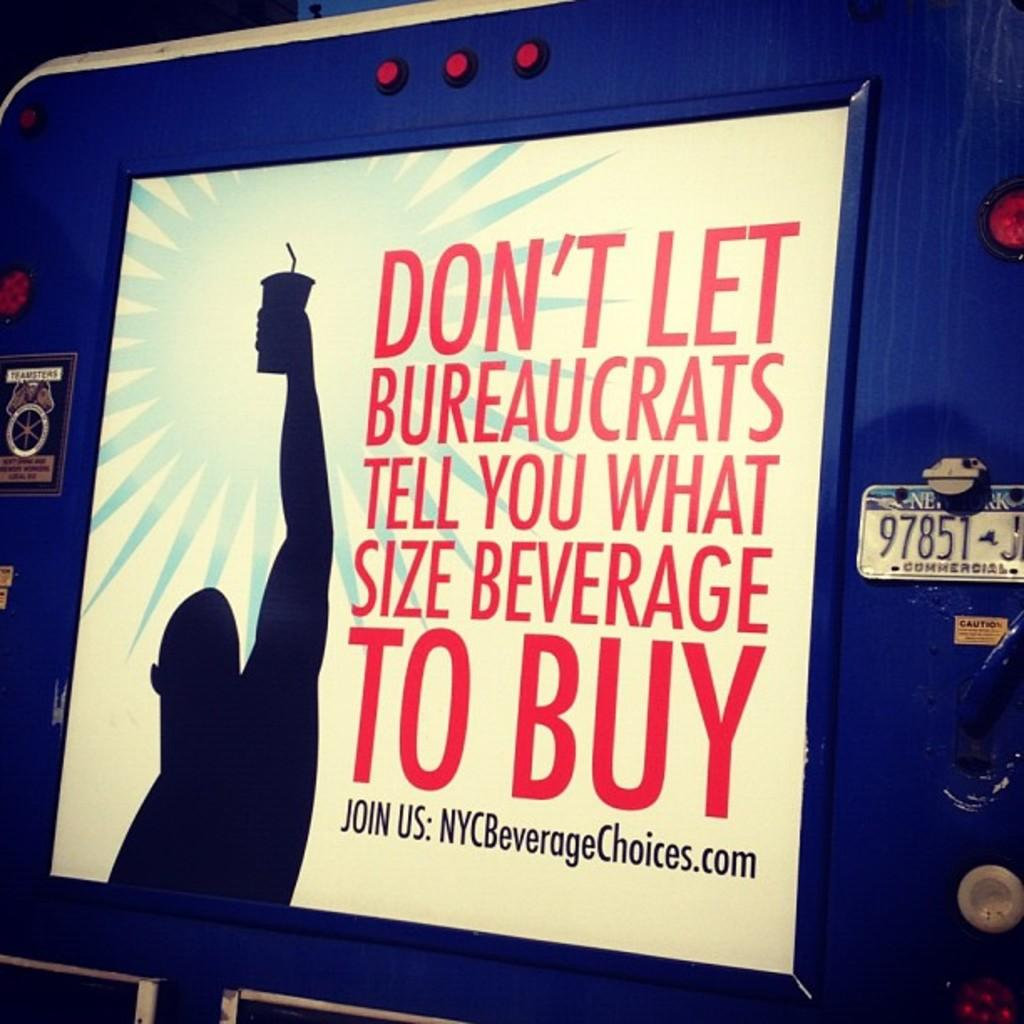<image>
Relay a brief, clear account of the picture shown. Sign on back of a trailer by NYCBeverageChoices.com. 